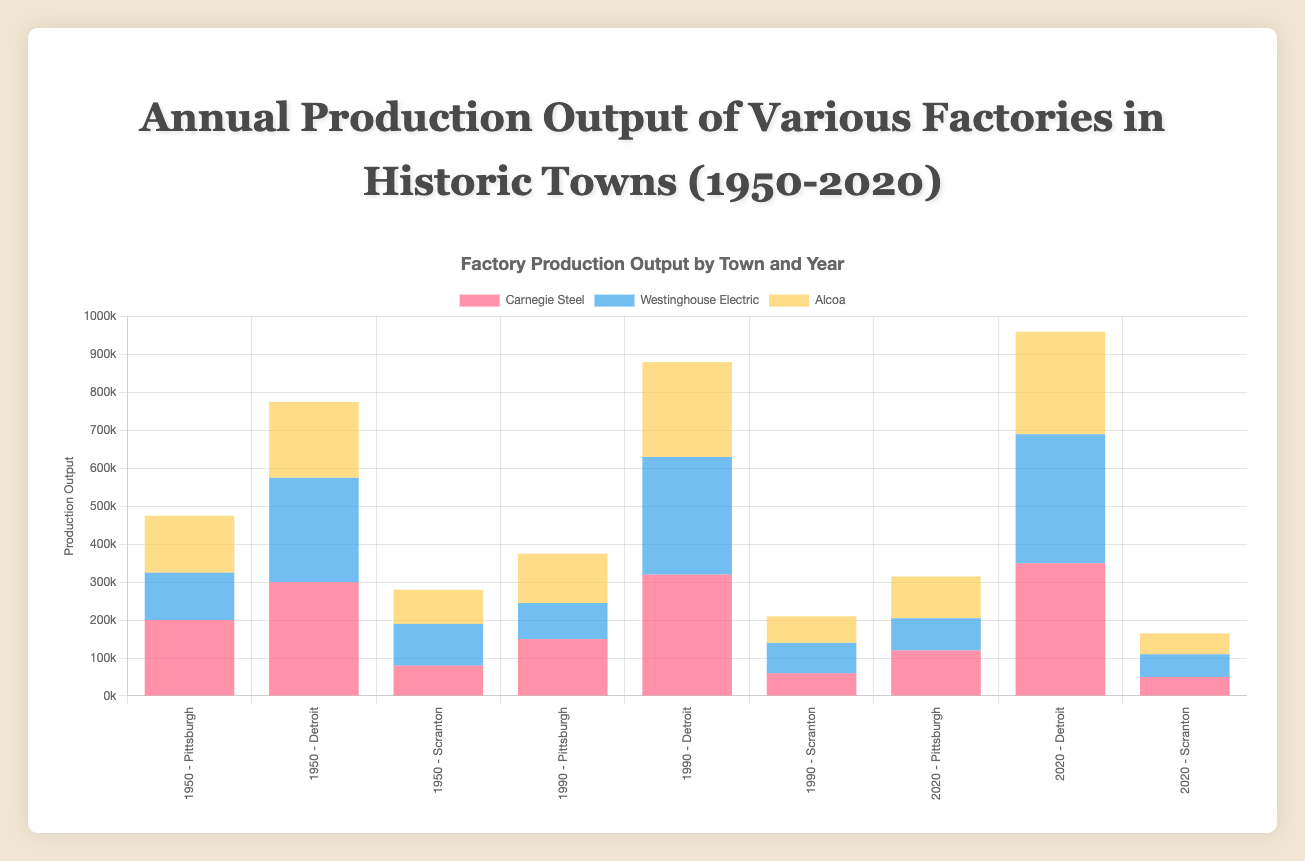Which factory had the highest production output in Detroit in 1950? First, locate the data for Detroit in 1950. Then identify the factory with the highest bar in that group. Ford Motor Company has the highest output.
Answer: Ford Motor Company How did the output of Alcoa in Pittsburgh change from 1950 to 2020? Find Alcoa's output in Pittsburgh for each of the given years. In 1950, Alcoa's output was 150,000. In 2020, it is 110,000. Calculate the difference: 150,000 - 110,000 = 40,000.
Answer: Decreased by 40,000 What is the sum of the production outputs of all factories in Scranton in 1990? Sum the outputs for Scranton's factories: Scranton Steel (60,000) + Pennsylvania Coal (80,000) + Lackawanna Iron and Steel (70,000) = 210,000.
Answer: 210,000 Which town had the largest growth in total production output from 1950 to 2020? Sum the total production outputs for each town in 1950 and 2020, then find the differences. Pittsburgh (475,000 to 315,000), Detroit (775,000 to 960,000), Scranton (280,000 to 165,000). Compare the differences: Pittsburgh (-160,000), Detroit (185,000), Scranton (-115,000).
Answer: Detroit Which factory in Pittsburgh had the lowest production output in 2020? Look at Pittsburgh's factory outputs for 2020. Identify the factory with the lowest bar height. Westinghouse Electric has the lowest output with 85,000.
Answer: Westinghouse Electric 